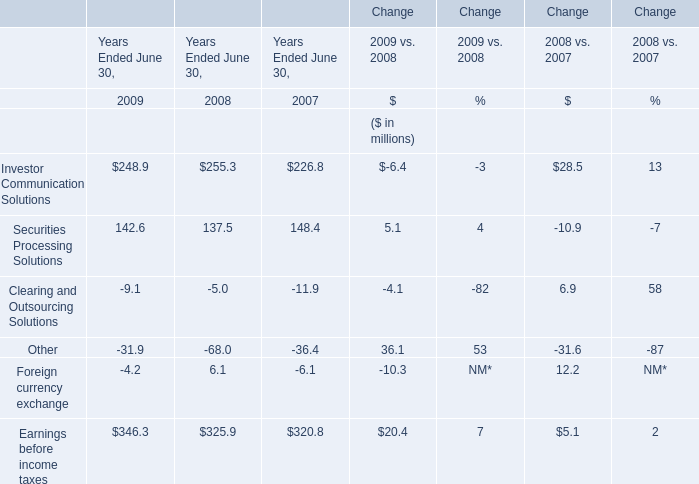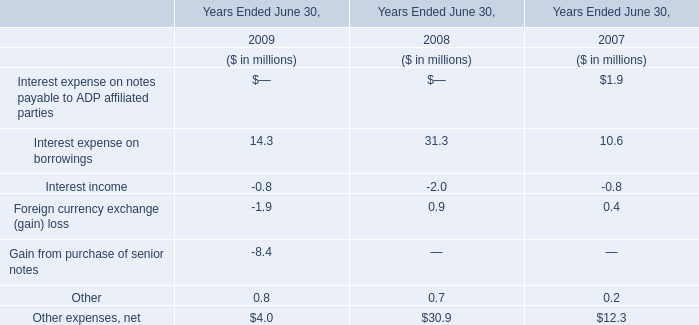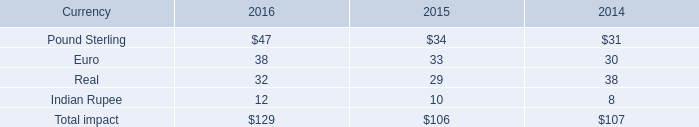What's the growth rate of Securities Processing Solutions in 2009? 
Answer: 4%. 